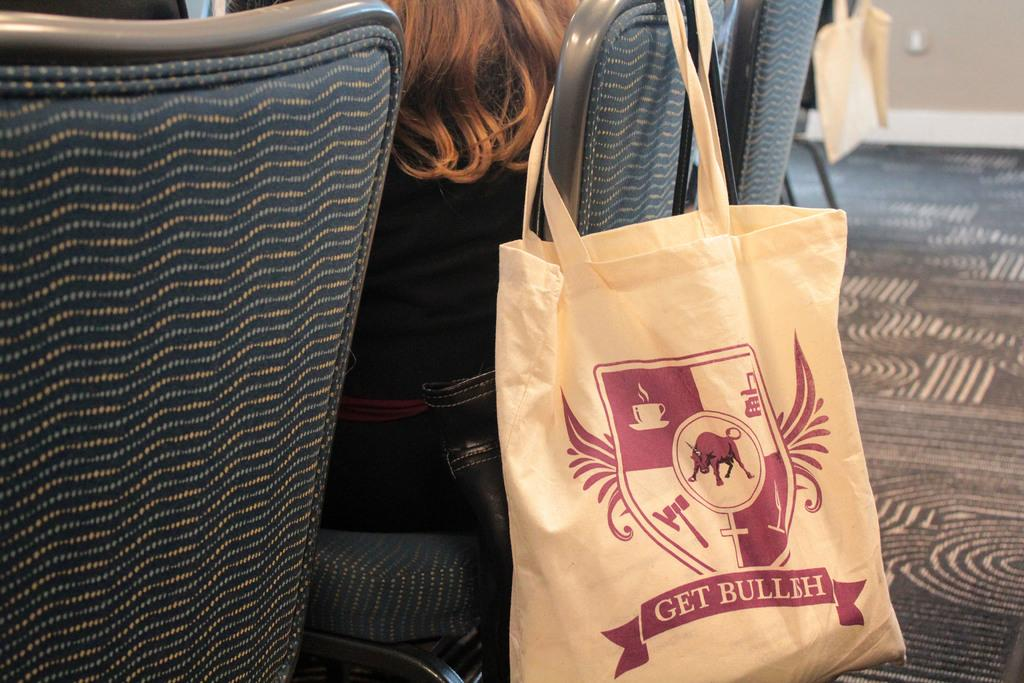What is the person in the image doing? The person is sitting on a chair. How many chairs are visible in the image? There are chairs on the floor. What is placed on the chairs? There are bags on the chairs. What can be seen in the background of the image? There is a wall in the background. What type of salt can be seen on the person's fang in the image? There is no salt or fang present in the image; the person is sitting on a chair with bags on the chairs and a wall in the background. 